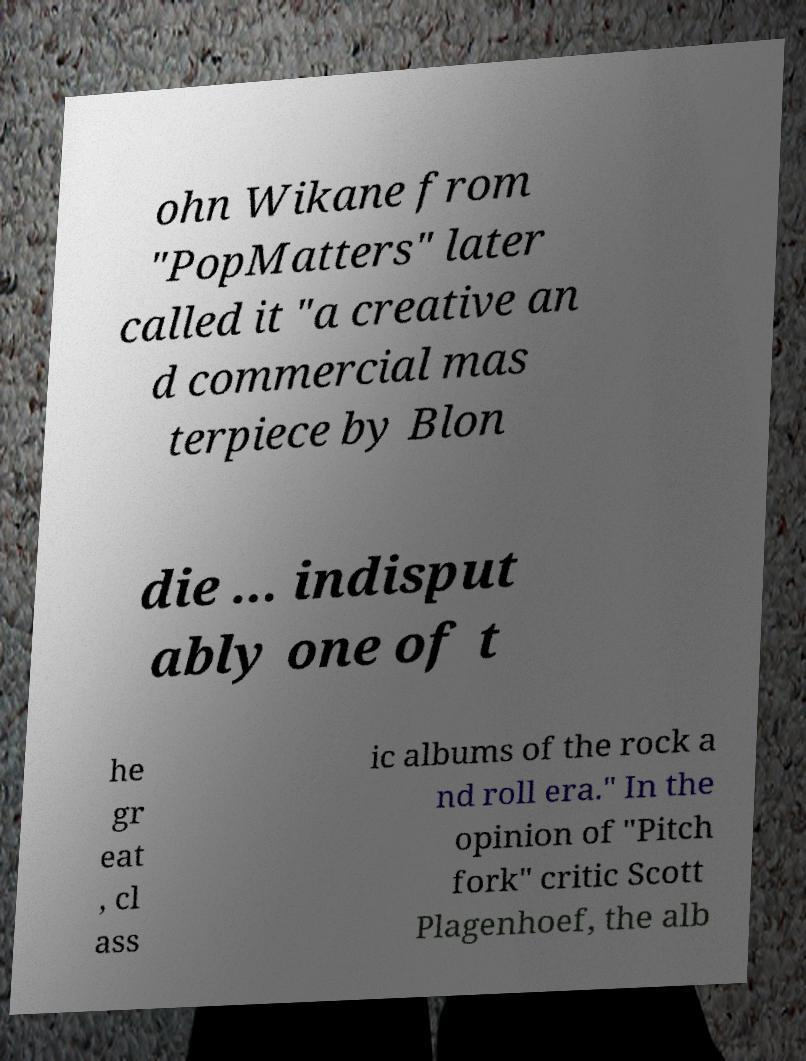What messages or text are displayed in this image? I need them in a readable, typed format. ohn Wikane from "PopMatters" later called it "a creative an d commercial mas terpiece by Blon die ... indisput ably one of t he gr eat , cl ass ic albums of the rock a nd roll era." In the opinion of "Pitch fork" critic Scott Plagenhoef, the alb 